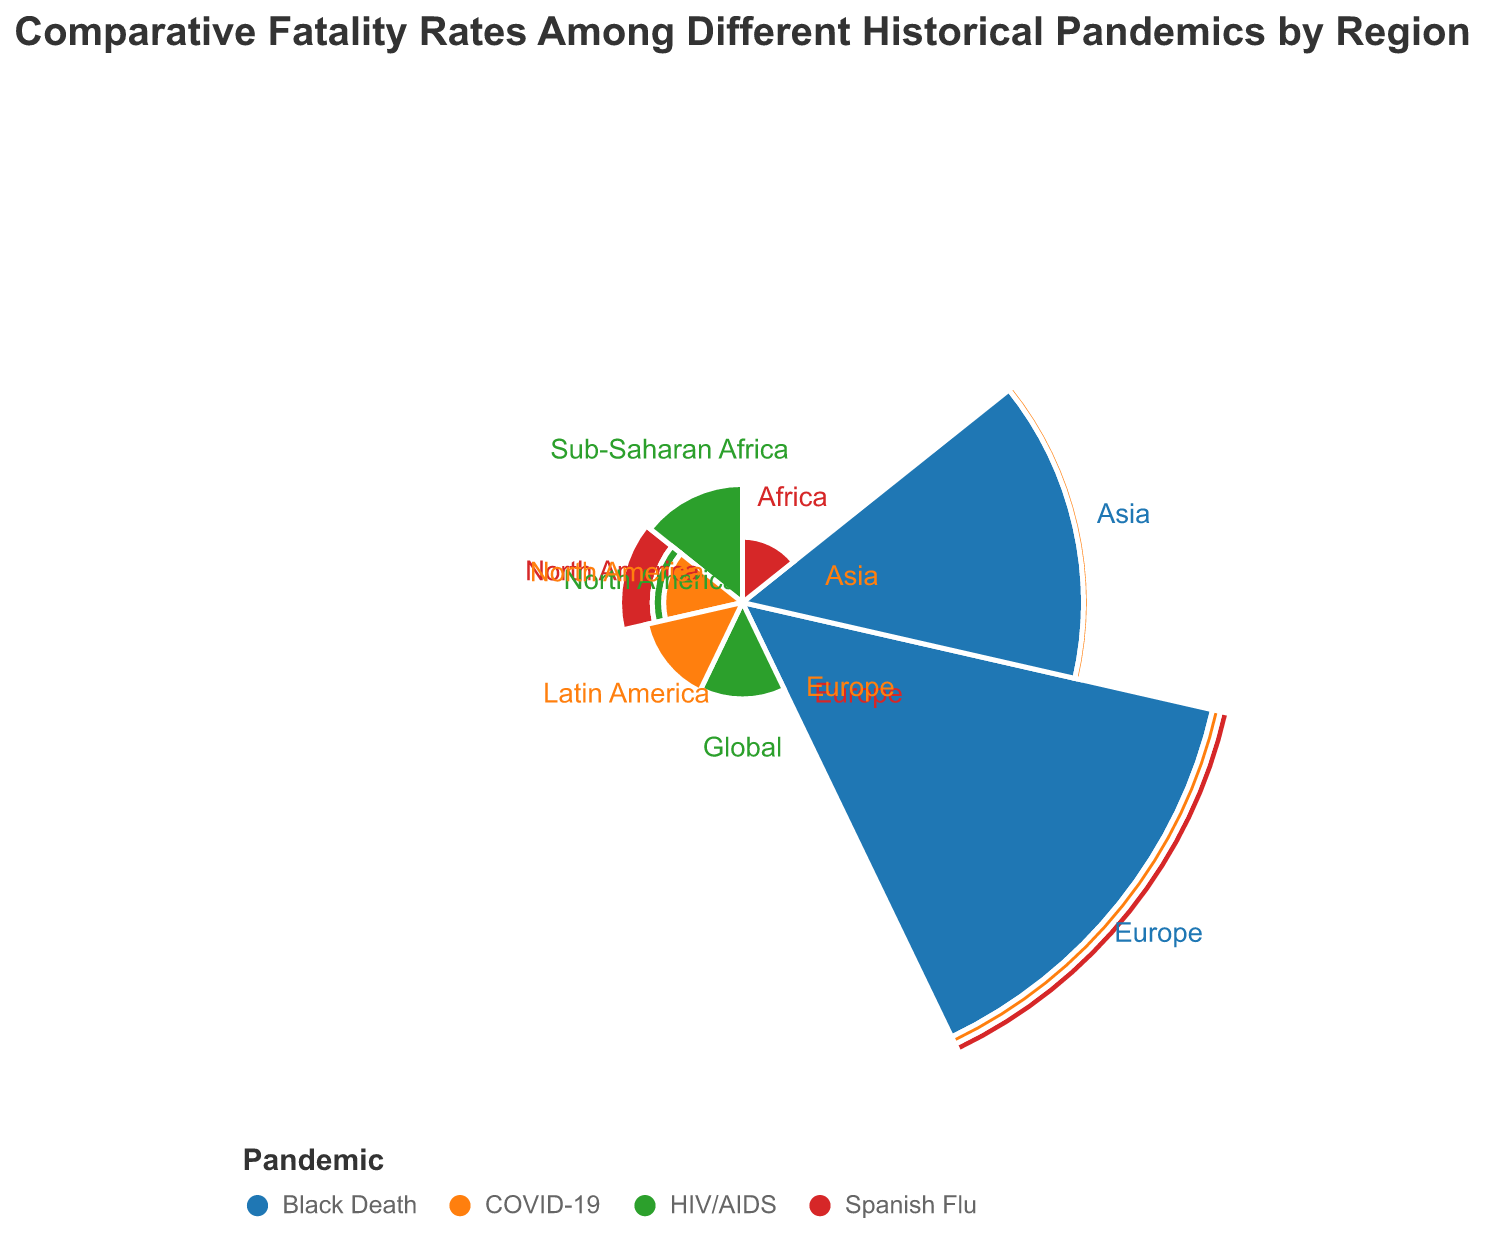How many regions are compared for the Black Death pandemic? By counting the regions labeled in the chart for the Black Death pandemic, we see Europe and Asia.
Answer: 2 Which pandemic has the highest fatality rate in any region? The chart shows Europe during the Black Death has the most extended arc, representing 60% fatality rate.
Answer: Black Death in Europe Compare the fatality rates of COVID-19 in North America and Latin America. Which is higher and by how much? The fatality rate for COVID-19 in North America is 1.6%, and in Latin America, it is 2.5%. The difference is 2.5% - 1.6% = 0.9%.
Answer: Latin America by 0.9% Which region experienced the highest fatality rate during the Spanish Flu? By observing the different arc sizes for the Spanish Flu pandemic, Europe has the largest arc at 2.5%.
Answer: Europe What is the sum of the fatality rates for HIV/AIDS across all specified regions? The fatality rates are Global 2.4%, Sub-Saharan Africa 3.6%, and North America 0.5%. Summing them up: 2.4 + 3.6 + 0.5 = 6.5%.
Answer: 6.5% Is the fatality rate in Asia higher for the Black Death or COVID-19? The Black Death in Asia shows an arc representing 30%, while COVID-19 shows 1%. 30% is greater than 1%.
Answer: Black Death Which pandemic shows the most variation in fatality rates across different regions and what are the values? By visual inspection, the Black Death has fatality rates of 60% in Europe and 30% in Asia, resulting in the most significant variation of 60% - 30% = 30%.
Answer: Black Death, 30% Which region has the highest fatality rate during COVID-19 and what is that rate? The largest arc for COVID-19 is for Latin America, which is 2.5%.
Answer: Latin America, 2.5% What is the average fatality rate for all regions during the Spanish Flu? The Spanish Flu has fatality rates of 1.8% in North America, 2.5% in Europe, and 1.1% in Africa. The average is (1.8 + 2.5 + 1.1) / 3 = 1.8%.
Answer: 1.8% 